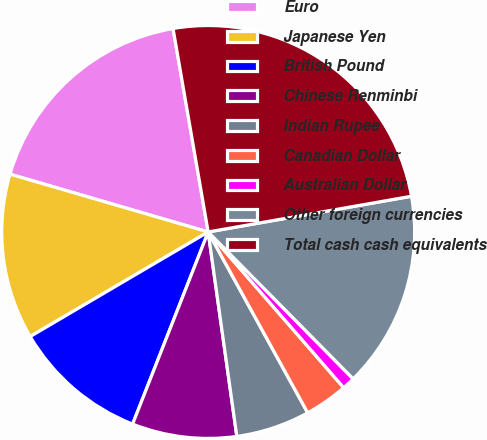Convert chart. <chart><loc_0><loc_0><loc_500><loc_500><pie_chart><fcel>Euro<fcel>Japanese Yen<fcel>British Pound<fcel>Chinese Renminbi<fcel>Indian Rupee<fcel>Canadian Dollar<fcel>Australian Dollar<fcel>Other foreign currencies<fcel>Total cash cash equivalents<nl><fcel>17.76%<fcel>12.97%<fcel>10.58%<fcel>8.18%<fcel>5.79%<fcel>3.39%<fcel>1.0%<fcel>15.37%<fcel>24.95%<nl></chart> 